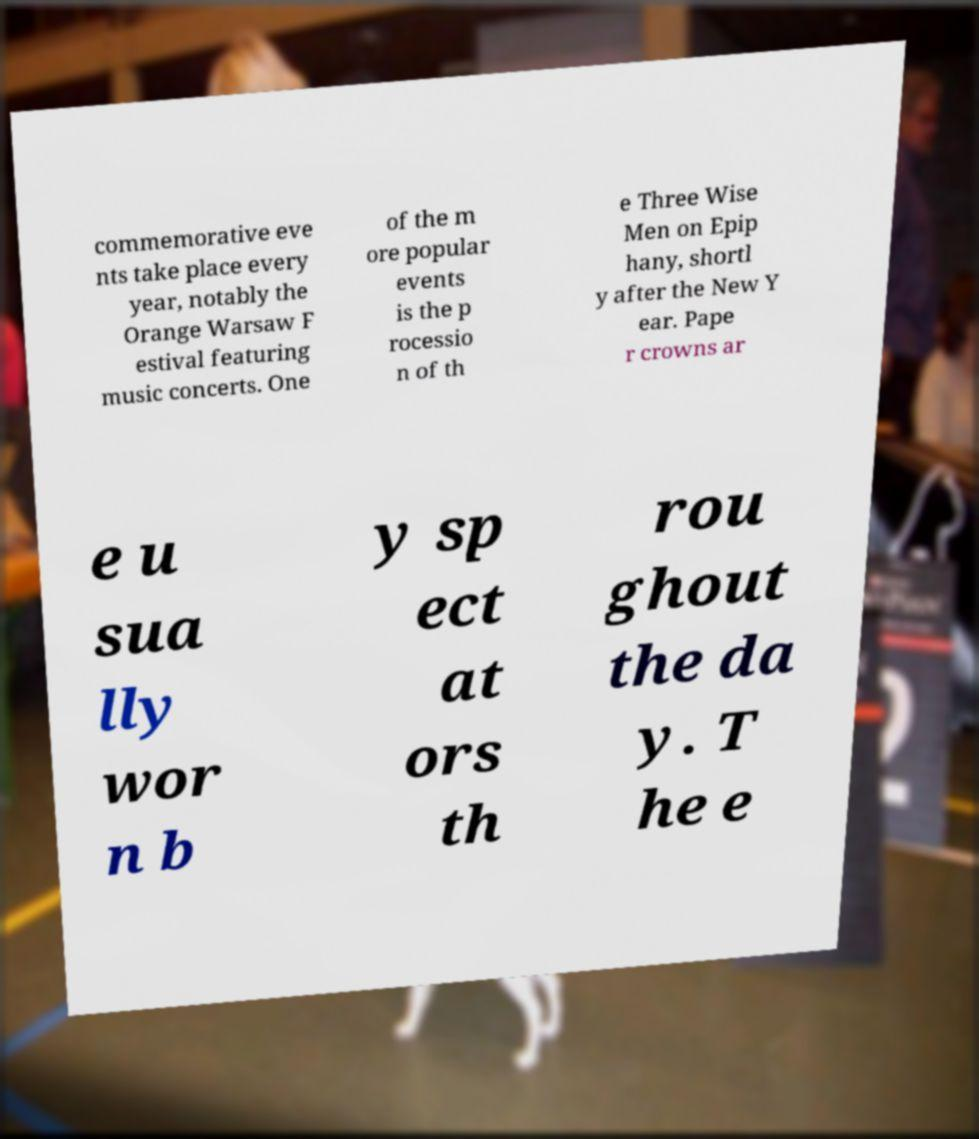What messages or text are displayed in this image? I need them in a readable, typed format. commemorative eve nts take place every year, notably the Orange Warsaw F estival featuring music concerts. One of the m ore popular events is the p rocessio n of th e Three Wise Men on Epip hany, shortl y after the New Y ear. Pape r crowns ar e u sua lly wor n b y sp ect at ors th rou ghout the da y. T he e 